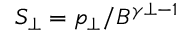Convert formula to latex. <formula><loc_0><loc_0><loc_500><loc_500>S _ { \perp } = p _ { \perp } / B ^ { \gamma { \perp } - 1 }</formula> 